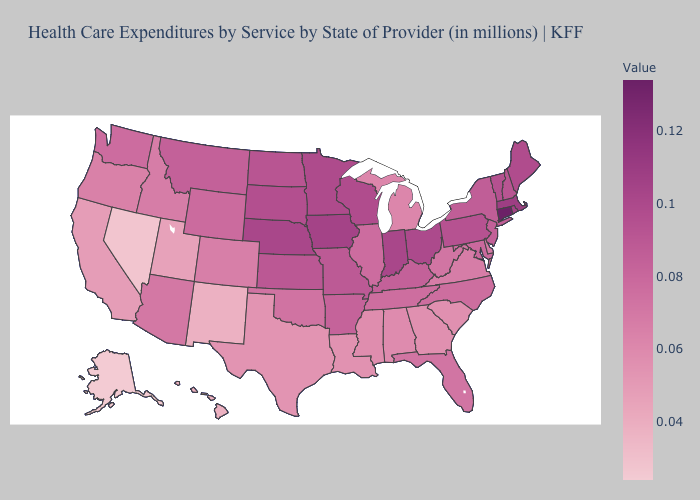Does Rhode Island have the lowest value in the Northeast?
Be succinct. No. Which states have the highest value in the USA?
Quick response, please. Connecticut. Which states hav the highest value in the West?
Quick response, please. Montana. Does Delaware have the lowest value in the South?
Give a very brief answer. No. Does California have a lower value than Alaska?
Keep it brief. No. Which states have the lowest value in the West?
Quick response, please. Alaska. Does Rhode Island have a higher value than Tennessee?
Write a very short answer. Yes. 